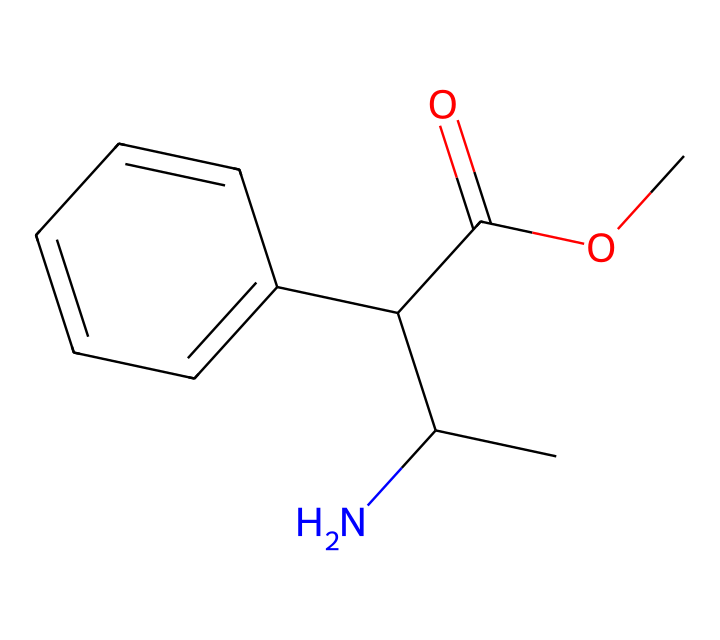What is the total number of carbon atoms in methylphenidate? The SMILES representation indicates the presence of several 'C' characters, representing carbon atoms. Counting them gives a total of 13 carbon atoms.
Answer: 13 How many stereocenters are present in methylphenidate? A stereocenter is a carbon atom that has four different substituents. In the SMILES of methylphenidate, there is one carbon atom attached to four distinct groups, indicating one stereocenter.
Answer: 1 What functional group is present in methylphenidate? The structure contains an ester functional group, which is identified by the presence of a carbonyl group (C=O) adjacent to an ether (C-O-C) linkage within its structure.
Answer: ester Which ring structure is identified in the chemical? The representation shows a benzene ring structure by the 'C1=CC=CC=C1' segment, which indicates the cyclic arrangement of six carbon atoms with alternating double bonds.
Answer: benzene Is methylphenidate considered a chiral compound? The presence of one stereocenter in the molecular structure confirms that methylphenidate can exist in two enantiomeric forms, thus categorizing it as a chiral compound.
Answer: yes 